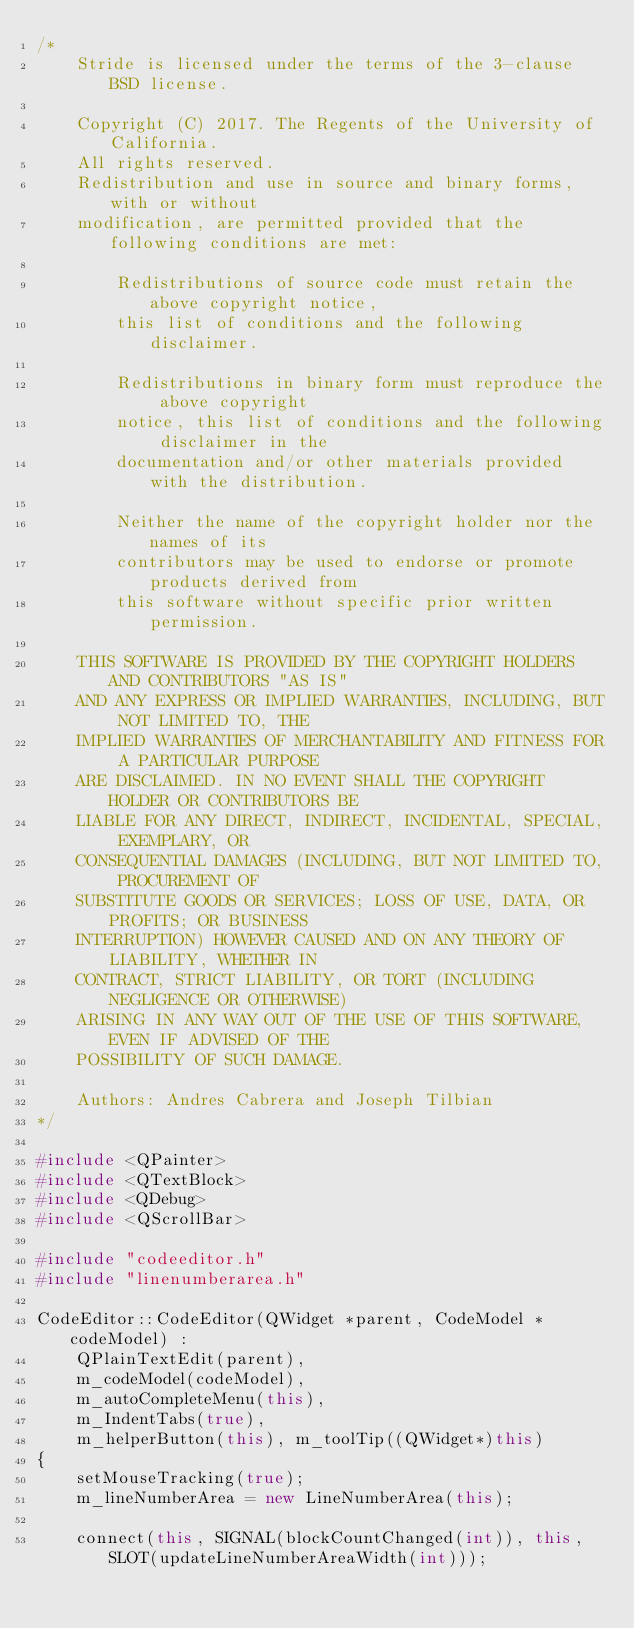<code> <loc_0><loc_0><loc_500><loc_500><_C++_>/*
    Stride is licensed under the terms of the 3-clause BSD license.

    Copyright (C) 2017. The Regents of the University of California.
    All rights reserved.
    Redistribution and use in source and binary forms, with or without
    modification, are permitted provided that the following conditions are met:

        Redistributions of source code must retain the above copyright notice,
        this list of conditions and the following disclaimer.

        Redistributions in binary form must reproduce the above copyright
        notice, this list of conditions and the following disclaimer in the
        documentation and/or other materials provided with the distribution.

        Neither the name of the copyright holder nor the names of its
        contributors may be used to endorse or promote products derived from
        this software without specific prior written permission.

    THIS SOFTWARE IS PROVIDED BY THE COPYRIGHT HOLDERS AND CONTRIBUTORS "AS IS"
    AND ANY EXPRESS OR IMPLIED WARRANTIES, INCLUDING, BUT NOT LIMITED TO, THE
    IMPLIED WARRANTIES OF MERCHANTABILITY AND FITNESS FOR A PARTICULAR PURPOSE
    ARE DISCLAIMED. IN NO EVENT SHALL THE COPYRIGHT HOLDER OR CONTRIBUTORS BE
    LIABLE FOR ANY DIRECT, INDIRECT, INCIDENTAL, SPECIAL, EXEMPLARY, OR
    CONSEQUENTIAL DAMAGES (INCLUDING, BUT NOT LIMITED TO, PROCUREMENT OF
    SUBSTITUTE GOODS OR SERVICES; LOSS OF USE, DATA, OR PROFITS; OR BUSINESS
    INTERRUPTION) HOWEVER CAUSED AND ON ANY THEORY OF LIABILITY, WHETHER IN
    CONTRACT, STRICT LIABILITY, OR TORT (INCLUDING NEGLIGENCE OR OTHERWISE)
    ARISING IN ANY WAY OUT OF THE USE OF THIS SOFTWARE, EVEN IF ADVISED OF THE
    POSSIBILITY OF SUCH DAMAGE.

    Authors: Andres Cabrera and Joseph Tilbian
*/

#include <QPainter>
#include <QTextBlock>
#include <QDebug>
#include <QScrollBar>

#include "codeeditor.h"
#include "linenumberarea.h"

CodeEditor::CodeEditor(QWidget *parent, CodeModel *codeModel) :
    QPlainTextEdit(parent),
    m_codeModel(codeModel),
    m_autoCompleteMenu(this),
    m_IndentTabs(true),
    m_helperButton(this), m_toolTip((QWidget*)this)
{
    setMouseTracking(true);
    m_lineNumberArea = new LineNumberArea(this);

    connect(this, SIGNAL(blockCountChanged(int)), this, SLOT(updateLineNumberAreaWidth(int)));</code> 